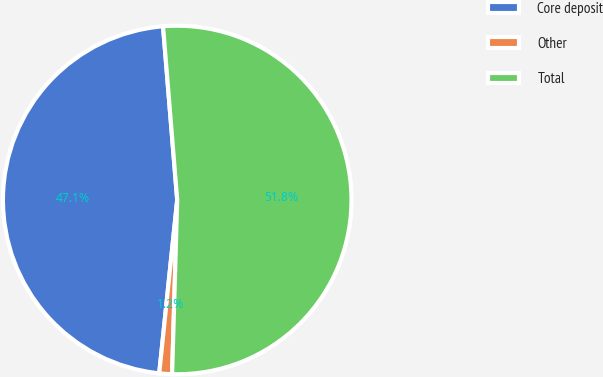Convert chart. <chart><loc_0><loc_0><loc_500><loc_500><pie_chart><fcel>Core deposit<fcel>Other<fcel>Total<nl><fcel>47.06%<fcel>1.18%<fcel>51.76%<nl></chart> 